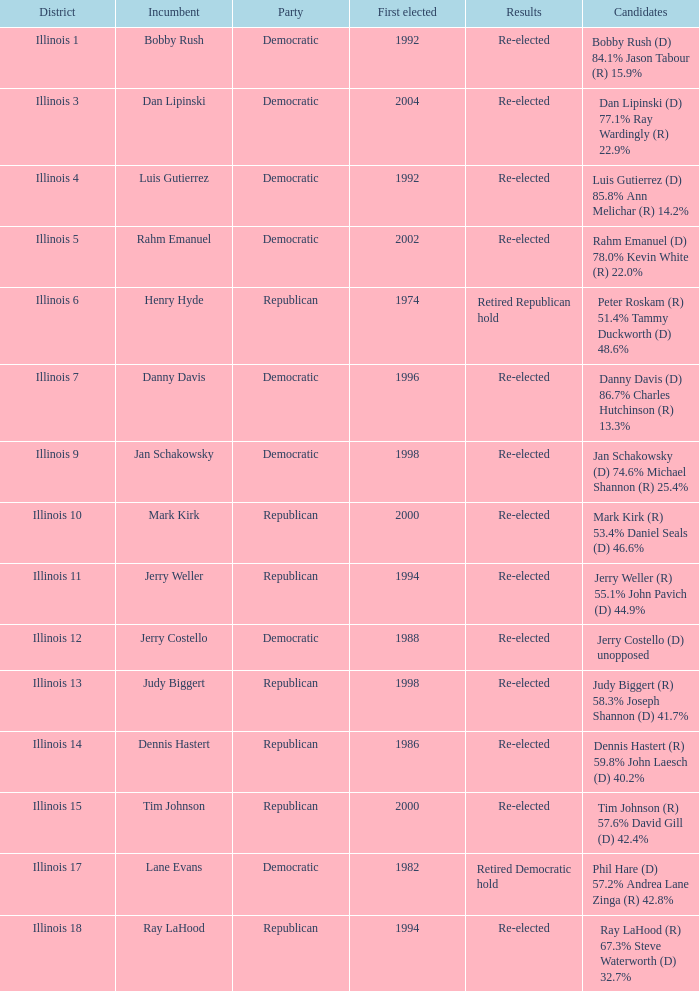What is the district when the first elected was in 1986? Illinois 14. 